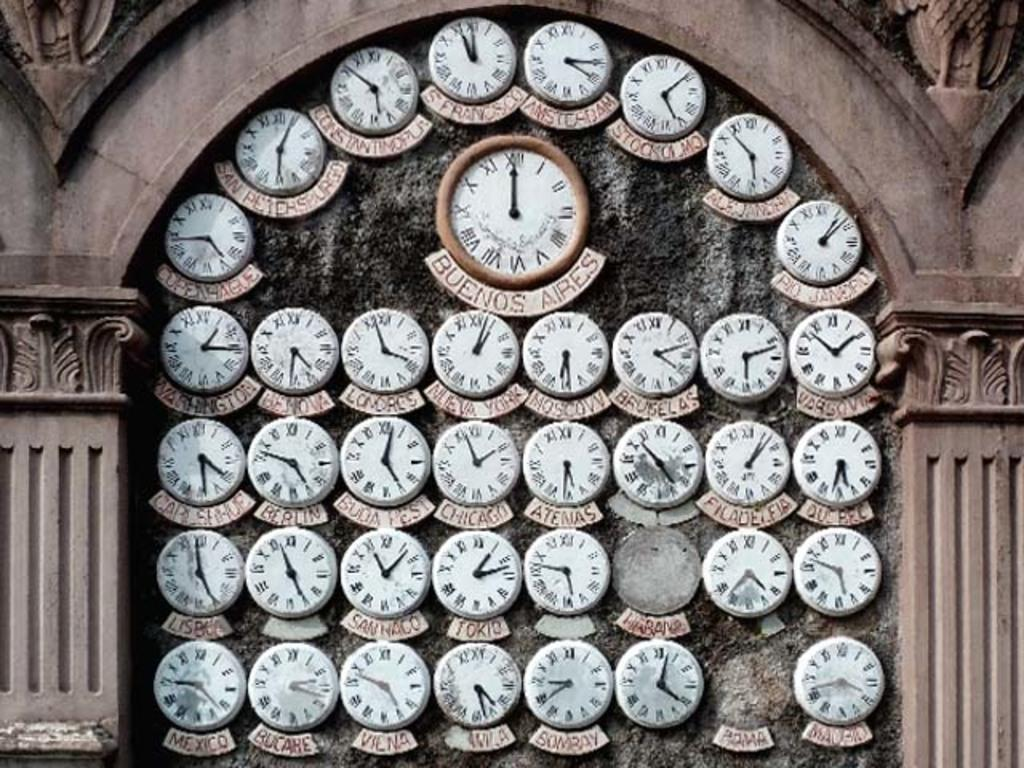<image>
Relay a brief, clear account of the picture shown. Small clocks showing the time in various cities surrounding a larger clock with the time in Buenos Aires. 